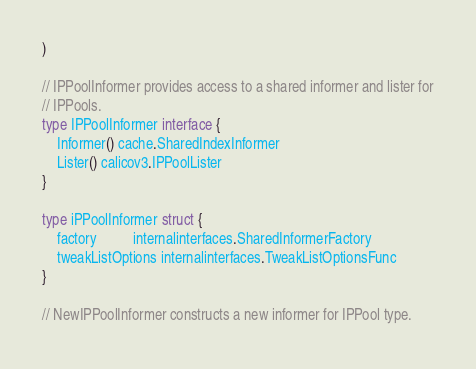<code> <loc_0><loc_0><loc_500><loc_500><_Go_>)

// IPPoolInformer provides access to a shared informer and lister for
// IPPools.
type IPPoolInformer interface {
	Informer() cache.SharedIndexInformer
	Lister() calicov3.IPPoolLister
}

type iPPoolInformer struct {
	factory          internalinterfaces.SharedInformerFactory
	tweakListOptions internalinterfaces.TweakListOptionsFunc
}

// NewIPPoolInformer constructs a new informer for IPPool type.</code> 